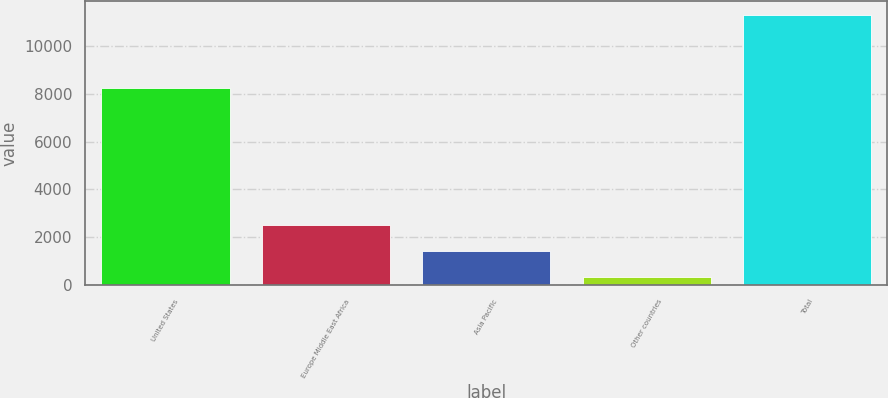<chart> <loc_0><loc_0><loc_500><loc_500><bar_chart><fcel>United States<fcel>Europe Middle East Africa<fcel>Asia Pacific<fcel>Other countries<fcel>Total<nl><fcel>8230<fcel>2531.4<fcel>1432.2<fcel>333<fcel>11325<nl></chart> 